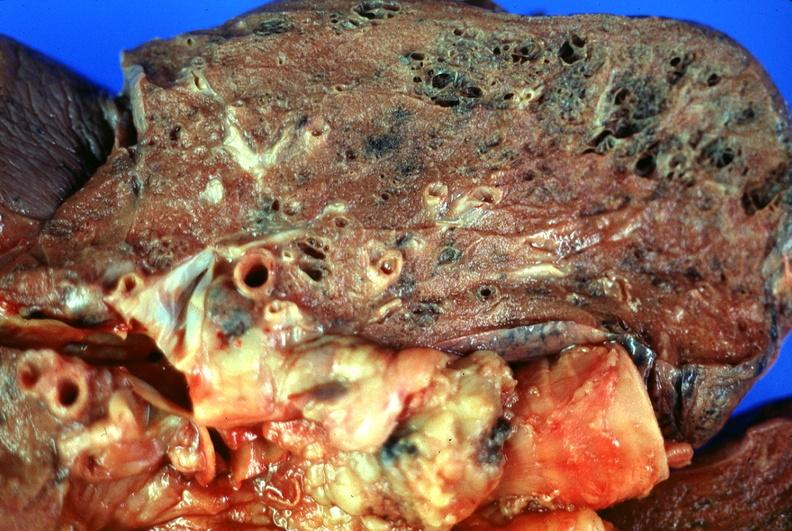does lymphoma show lung, emphysema?
Answer the question using a single word or phrase. No 